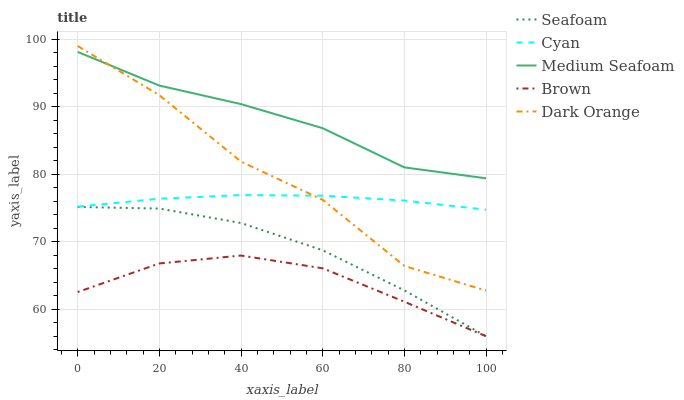Does Brown have the minimum area under the curve?
Answer yes or no. Yes. Does Medium Seafoam have the maximum area under the curve?
Answer yes or no. Yes. Does Cyan have the minimum area under the curve?
Answer yes or no. No. Does Cyan have the maximum area under the curve?
Answer yes or no. No. Is Cyan the smoothest?
Answer yes or no. Yes. Is Dark Orange the roughest?
Answer yes or no. Yes. Is Seafoam the smoothest?
Answer yes or no. No. Is Seafoam the roughest?
Answer yes or no. No. Does Seafoam have the lowest value?
Answer yes or no. Yes. Does Cyan have the lowest value?
Answer yes or no. No. Does Dark Orange have the highest value?
Answer yes or no. Yes. Does Cyan have the highest value?
Answer yes or no. No. Is Seafoam less than Medium Seafoam?
Answer yes or no. Yes. Is Medium Seafoam greater than Cyan?
Answer yes or no. Yes. Does Dark Orange intersect Cyan?
Answer yes or no. Yes. Is Dark Orange less than Cyan?
Answer yes or no. No. Is Dark Orange greater than Cyan?
Answer yes or no. No. Does Seafoam intersect Medium Seafoam?
Answer yes or no. No. 